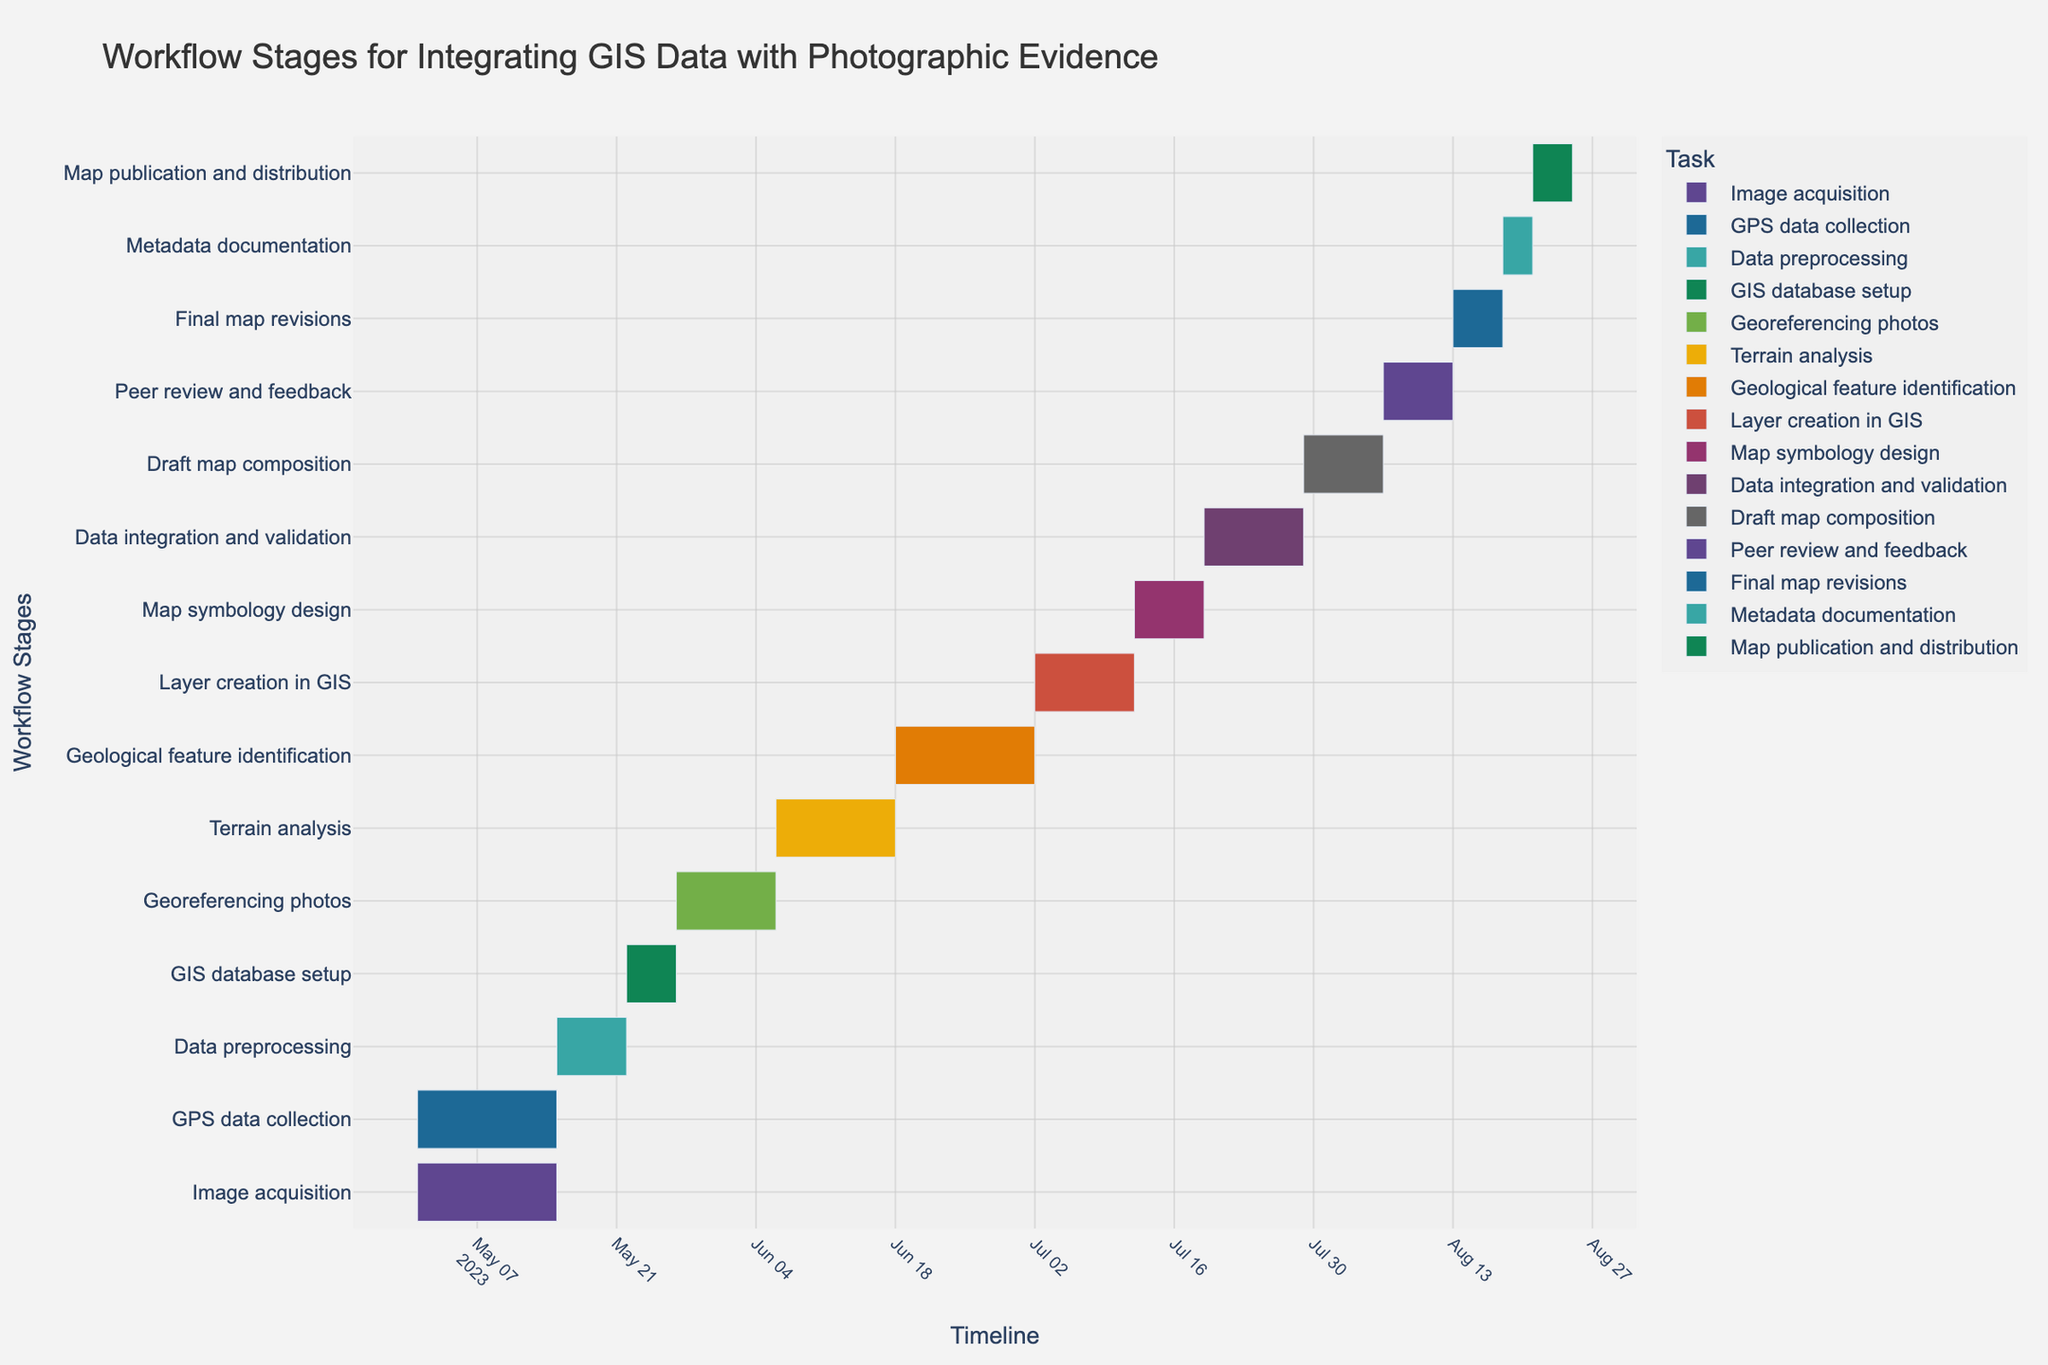Which task marks the beginning of the workflow? By examining the Gantt chart, the task at the top of the timeline generally marks the beginning. The first task listed is "Image acquisition," which starts on May 1, 2023.
Answer: Image acquisition Which task takes the longest to complete? To determine the task duration, look at the length of each bar and their respective durations. "Geological feature identification" takes 14 days, which is the longest among the listed tasks.
Answer: Geological feature identification How many tasks are scheduled to start in May? By examining the start dates of the bars in the Gantt chart within the month of May, the tasks are "Image acquisition," "GPS data collection," "Data preprocessing," "GIS database setup," and "Georeferencing photos," totaling 5 tasks.
Answer: 5 Which tasks are overlapping and share the same start date? Check the Gantt chart for tasks that start on the same date. "Image acquisition" and "GPS data collection" both start on May 1, 2023.
Answer: Image acquisition, GPS data collection What is the collective duration of all tasks? Add the duration of all tasks together: 14 (Image acquisition) + 14 (GPS data collection) + 7 (Data preprocessing) + 5 (GIS database setup) + 10 (Georeferencing photos) + 12 (Terrain analysis) + 14 (Geological feature identification) + 10 (Layer creation in GIS) + 7 (Map symbology design) + 10 (Data integration and validation) + 8 (Draft map composition) + 7 (Peer review and feedback) + 5 (Final map revisions) + 3 (Metadata documentation) + 4 (Map publication and distribution) = 130 days.
Answer: 130 days Which tasks are scheduled to end in July? Look at the end dates of the tasks falling within the month of July. "Geological feature identification" ends on July 2 and "Layer creation in GIS" ends on July 12.
Answer: Geological feature identification, Layer creation in GIS What is the median duration of the tasks? List out the durations and find the median. The durations are [3, 4, 5, 5, 7, 7, 7, 8, 10, 10, 10, 12, 14, 14] and the median is the average of the 7th and 8th numbers: (7 + 8) / 2 = 7.5 days.
Answer: 7.5 days Which task is directly followed by "Draft map composition"? To find this, check the timeline of the Gantt chart for the task that begins right after the "Draft map composition" ends. "Peer review and feedback" starts on August 6, the day after "Draft map composition" ends.
Answer: Peer review and feedback How much time is there between the start of "Image acquisition" and the end of "Terrain analysis"? Calculate the days between May 1, 2023 (start of "Image acquisition") and June 18, 2023 (end of "Terrain analysis"). The total duration is 48 days.
Answer: 48 days Which task has the shortest duration, and what is that duration? Reviewing the tasks and their durations, "Metadata documentation" has the shortest duration of 3 days.
Answer: Metadata documentation, 3 days 